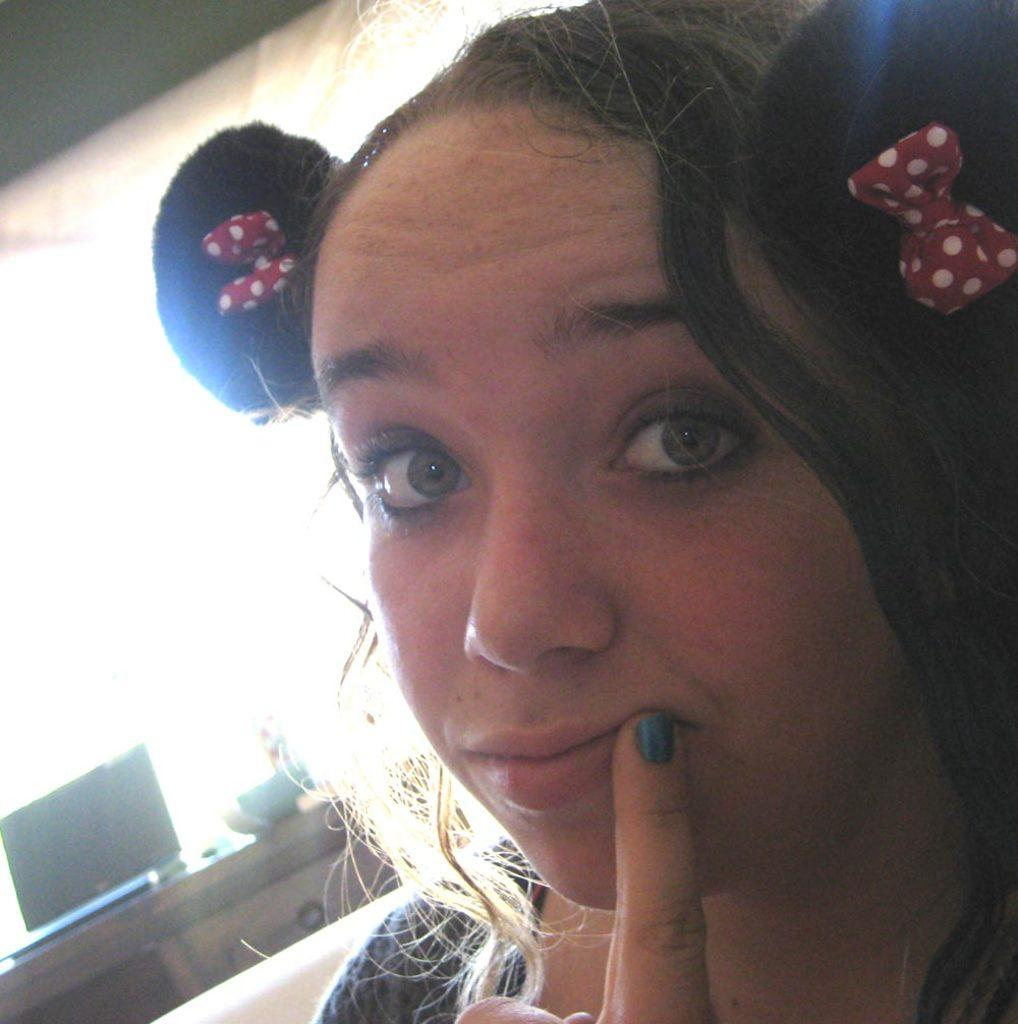Who is the main subject in the image? There is a lady in the image. What can be seen in the background of the image? There is a table in the background of the image. What is on the table in the image? There is a laptop on the table. How would you describe the background of the image? The background is blurry. How many balls are visible on the table in the image? There are no balls visible on the table in the image; only a laptop is present. 